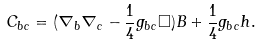Convert formula to latex. <formula><loc_0><loc_0><loc_500><loc_500>C _ { b c } = ( \nabla _ { b } \nabla _ { c } - \frac { 1 } { 4 } g _ { b c } \Box ) B + \frac { 1 } { 4 } g _ { b c } h .</formula> 